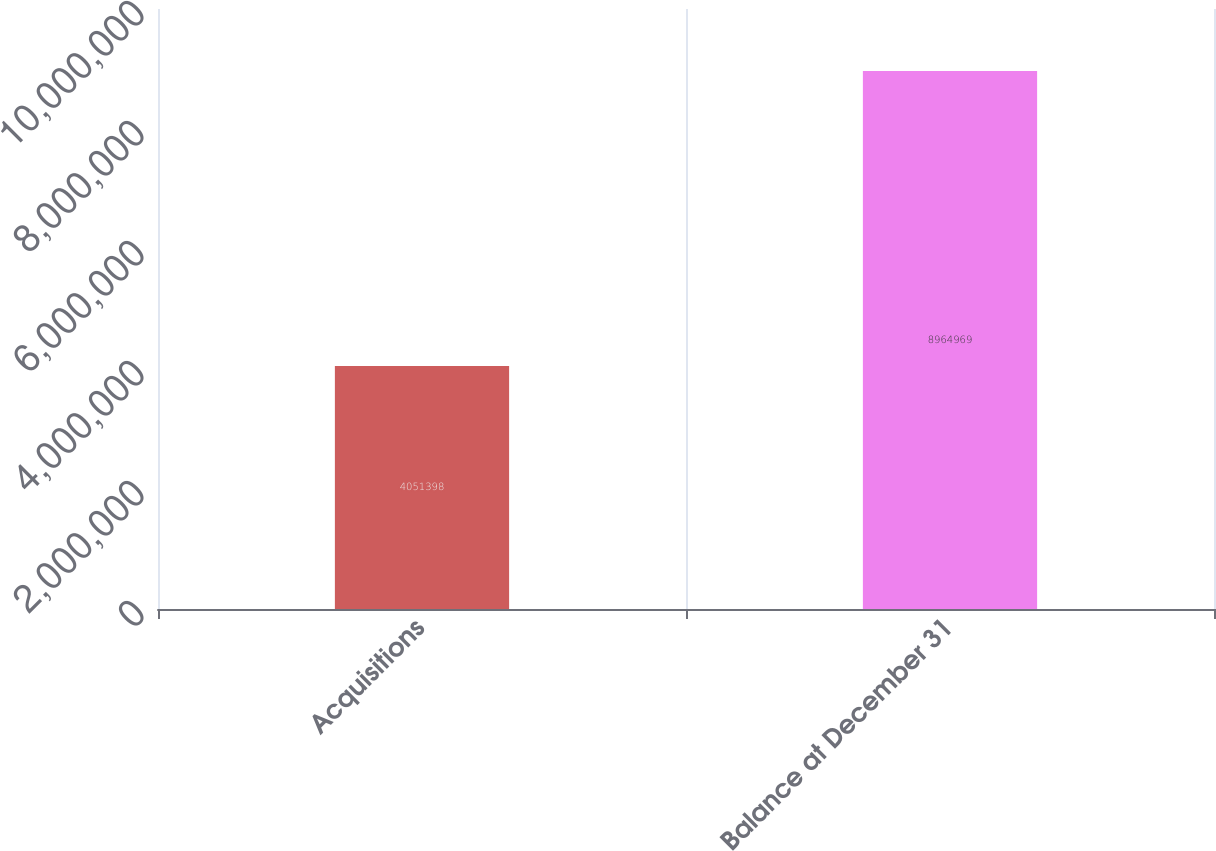Convert chart. <chart><loc_0><loc_0><loc_500><loc_500><bar_chart><fcel>Acquisitions<fcel>Balance at December 31<nl><fcel>4.0514e+06<fcel>8.96497e+06<nl></chart> 